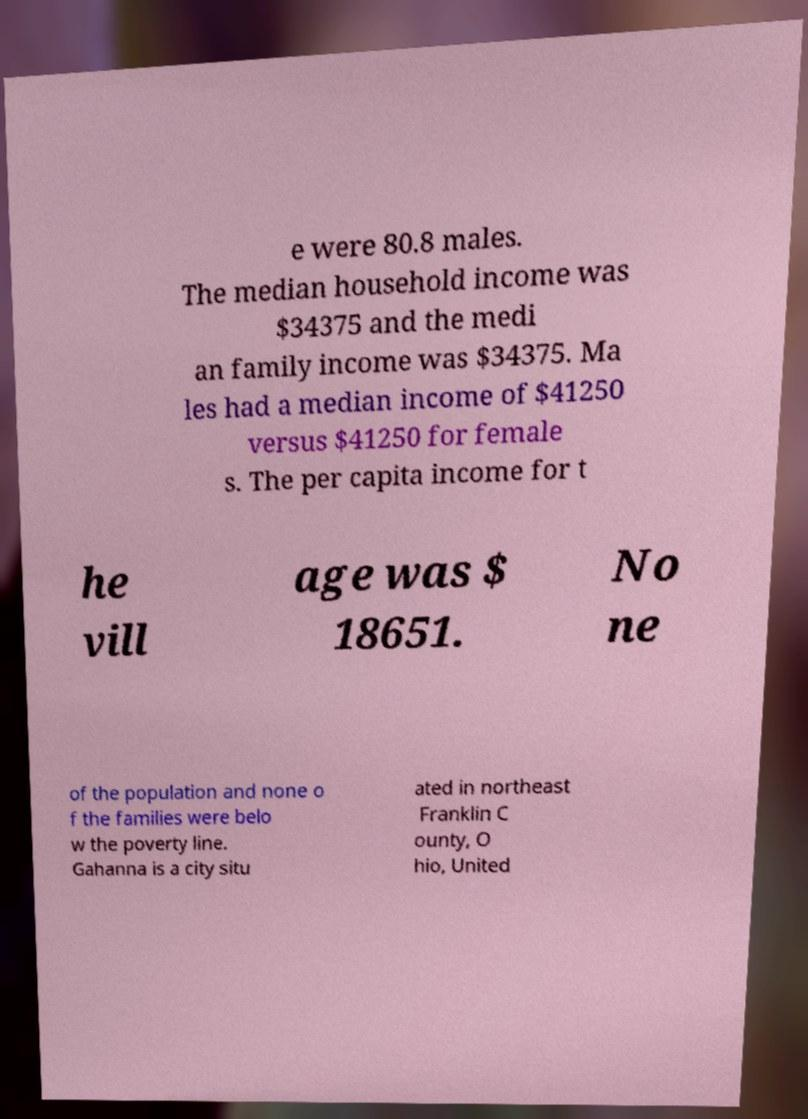Can you accurately transcribe the text from the provided image for me? e were 80.8 males. The median household income was $34375 and the medi an family income was $34375. Ma les had a median income of $41250 versus $41250 for female s. The per capita income for t he vill age was $ 18651. No ne of the population and none o f the families were belo w the poverty line. Gahanna is a city situ ated in northeast Franklin C ounty, O hio, United 